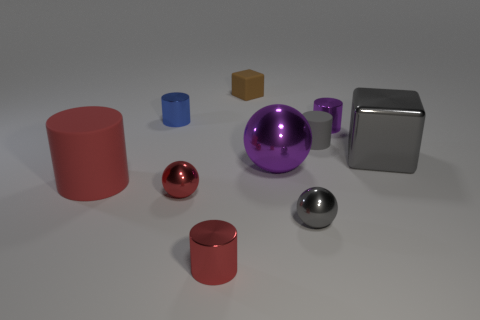What shape is the brown matte thing?
Give a very brief answer. Cube. How many other matte things are the same shape as the big gray thing?
Your response must be concise. 1. What number of tiny things are both behind the gray shiny sphere and on the right side of the large purple sphere?
Your answer should be very brief. 2. The big ball has what color?
Provide a short and direct response. Purple. Is there a tiny green cylinder that has the same material as the big purple sphere?
Keep it short and to the point. No. Is there a object that is on the right side of the red cylinder that is behind the small shiny ball to the left of the brown matte object?
Provide a short and direct response. Yes. Are there any small blue metallic cylinders in front of the tiny red shiny cylinder?
Ensure brevity in your answer.  No. Is there a tiny rubber block that has the same color as the metallic cube?
Offer a terse response. No. How many tiny things are green metallic blocks or red things?
Give a very brief answer. 2. Do the tiny gray thing that is behind the red matte thing and the large cylinder have the same material?
Offer a terse response. Yes. 